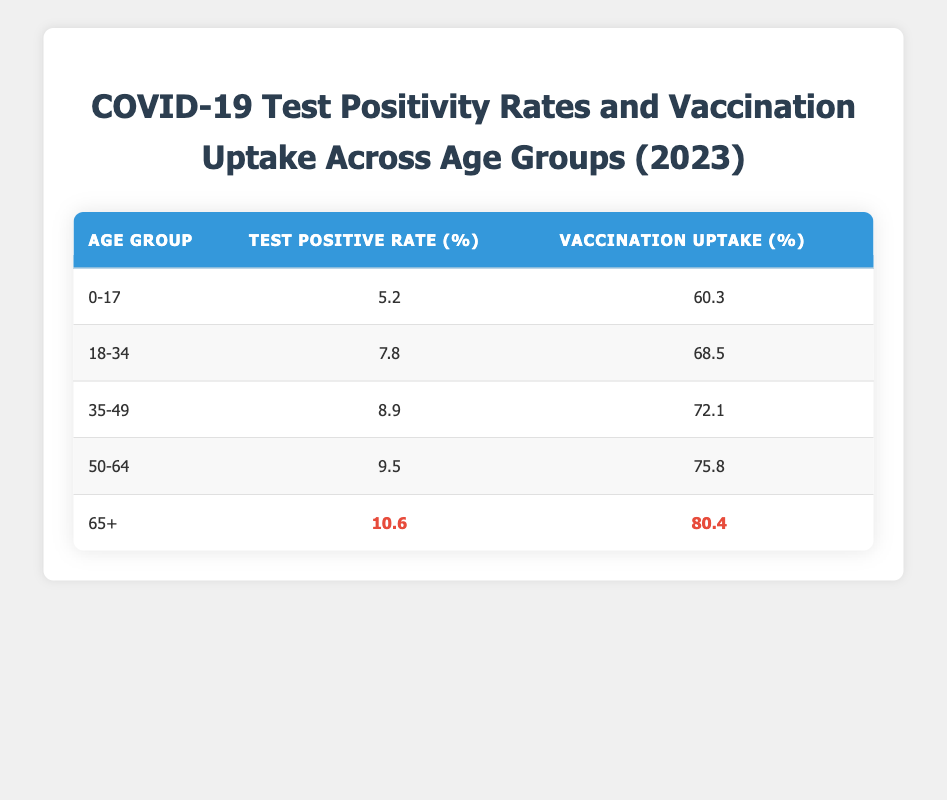What is the highest test positive rate among the age groups? The table shows the test positive rates for each age group. I compare the percentages and find that the highest test positive rate is for the age group 65+, which is 10.6%.
Answer: 10.6% What is the vaccination uptake percentage for the age group 35-49? The table lists the vaccination uptake percentage specifically for the 35-49 age group as 72.1%.
Answer: 72.1% Is the test positive rate for the age group 50-64 higher than that for the age group 18-34? I compare the test positive rates: 9.5% for age group 50-64 and 7.8% for age group 18-34. Since 9.5% is greater than 7.8%, the statement is true.
Answer: Yes What is the difference in vaccination uptake percentage between the age groups 0-17 and 65+? I retrieve the vaccination uptake percentages: 60.3% for 0-17 and 80.4% for 65+. The difference is calculated as 80.4% - 60.3% = 20.1%.
Answer: 20.1% What is the average test positive rate across all age groups? I sum the test positive rates (5.2 + 7.8 + 8.9 + 9.5 + 10.6 = 42) and then divide by the number of age groups (5). Thus, the average rate is 42 / 5 = 8.4%.
Answer: 8.4% Which age group has the lowest vaccination uptake percentage? I check the vaccination uptake percentages for each age group and find that the lowest is 60.3%, which belongs to the age group 0-17.
Answer: 0-17 Is the vaccination uptake percentage for the age group 50-64 above 70%? The vaccination uptake percentage for 50-64 is 75.8%, which is more than 70%. Therefore, the statement is true.
Answer: Yes What would be the combined test positive rate for the age groups 0-17 and 18-34? I locate the test positive rates for both age groups: 5.2% for 0-17 and 7.8% for 18-34. Combining these gives 5.2% + 7.8% = 13.0%.
Answer: 13.0% What percentage of the age group 35-49 had a test positive rate lower than the age group 65+? I check the rates: 8.9% for 35-49 and 10.6% for 65+. Since 8.9% is indeed lower than 10.6%, the statement is true.
Answer: Yes 